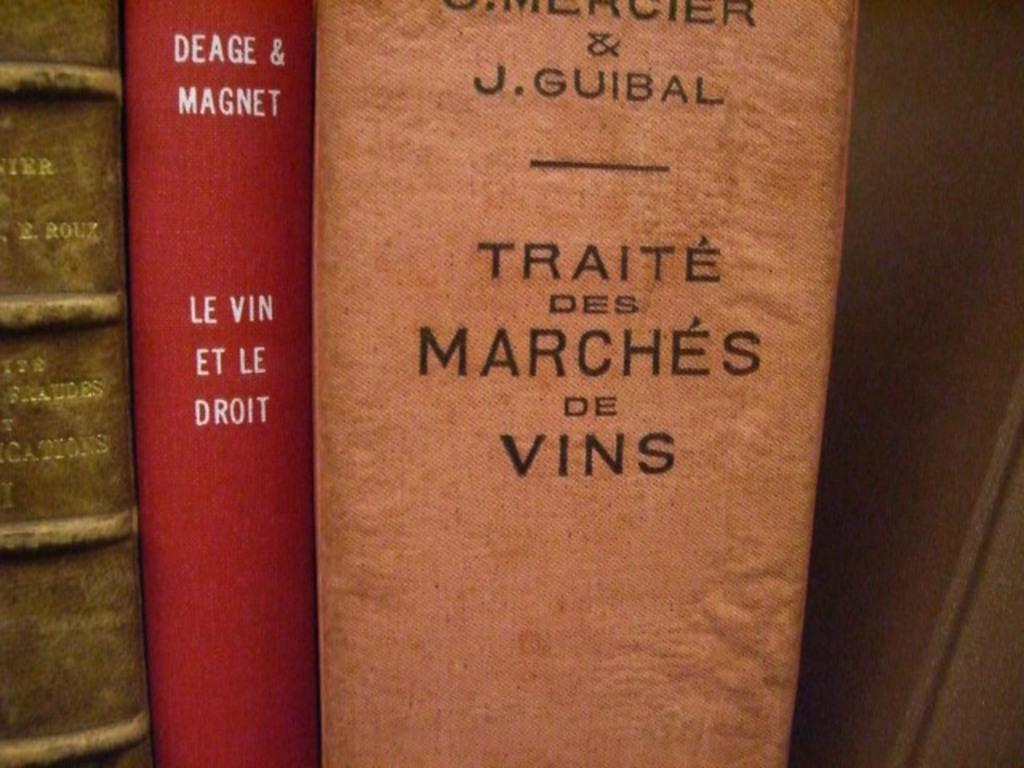What objects can be seen in the image? There are books in the image. Where are the books located? The books are on a shelf. What can be read on the books? There is text visible on the books. What type of grain is being sold in the store in the image? There is no store or grain present in the image; it features books on a shelf. What musical instrument is being played by the person in the image? There is no person or musical instrument present in the image; it only shows books on a shelf. 